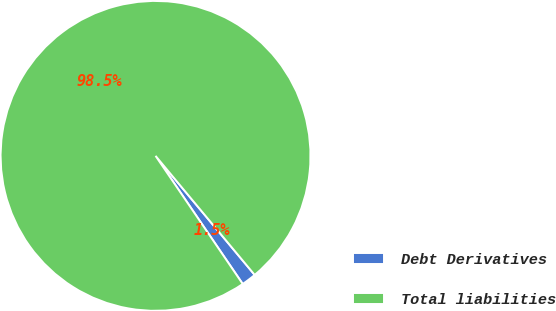<chart> <loc_0><loc_0><loc_500><loc_500><pie_chart><fcel>Debt Derivatives<fcel>Total liabilities<nl><fcel>1.54%<fcel>98.46%<nl></chart> 